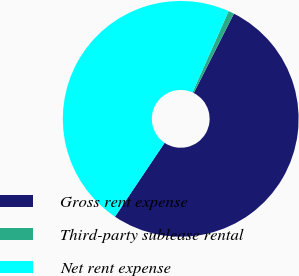<chart> <loc_0><loc_0><loc_500><loc_500><pie_chart><fcel>Gross rent expense<fcel>Third-party sublease rental<fcel>Net rent expense<nl><fcel>51.97%<fcel>0.79%<fcel>47.25%<nl></chart> 